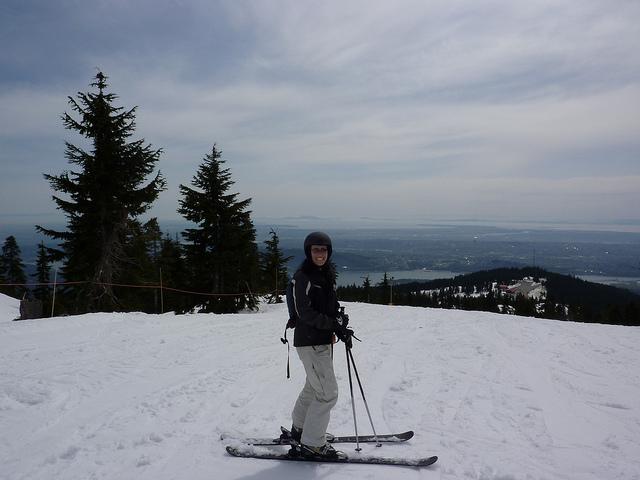Is she going fast?
Concise answer only. No. What color are the woman's pants?
Quick response, please. White. How's the weather?
Give a very brief answer. Cold. What does the person have on his feet?
Keep it brief. Skis. What's the lady getting ready to do?
Short answer required. Ski. Is the snow deep?
Short answer required. No. Is it a sunny day?
Answer briefly. No. Are there many skis?
Answer briefly. No. Is there an avalanche taking place?
Quick response, please. No. 